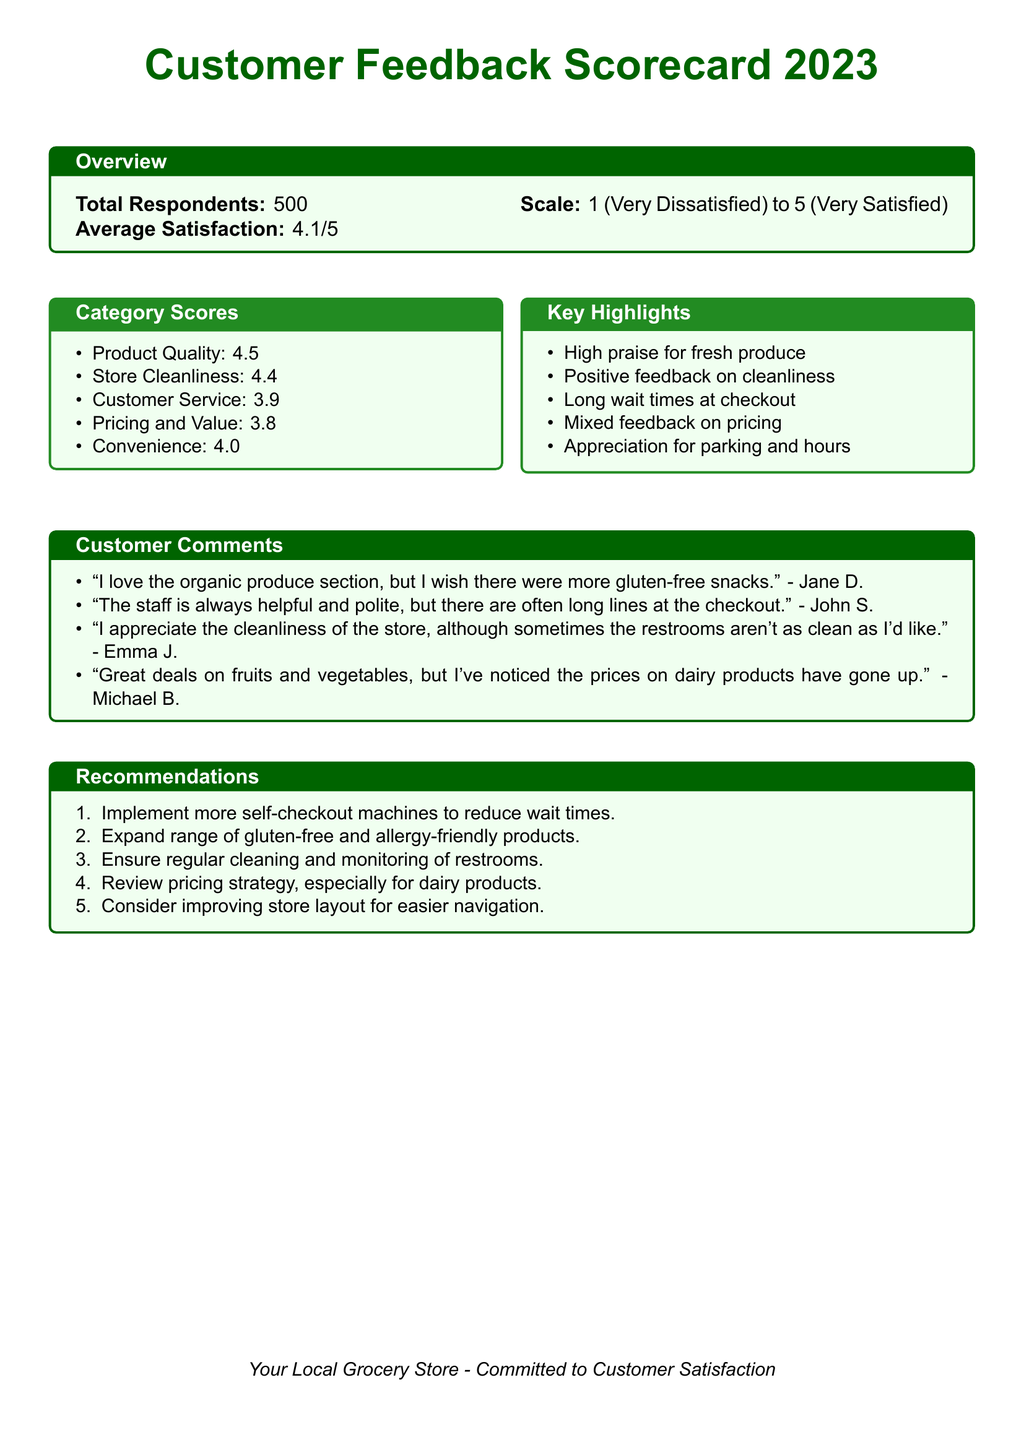What is the total number of respondents? The total number of respondents is stated in the document under the overview section.
Answer: 500 What is the average satisfaction score? The average satisfaction is provided in the overview section of the scorecard.
Answer: 4.1/5 What category received the highest score? The category scores are listed, and the highest score indicates the best-performing aspect.
Answer: Product Quality What issue was highlighted regarding customer service? A key highlight mentions the customers' experience with long wait times at checkout, indicating an issue.
Answer: Long wait times at checkout How many categories were assessed in the feedback? The number of categories can be counted from the category scores section of the document.
Answer: 5 What is a recommendation related to checkout lines? The recommendations list suggests ways to improve service, particularly concerning checkout efficiency.
Answer: Implement more self-checkout machines Which feature did customers appreciate regarding store facilities? The key highlights indicate customer satisfaction with specific store features, mentioned in the feedback section.
Answer: Parking and hours What did Jane D. comment on? The customer comments section lists specific feedback, including Jane D.'s suggestions.
Answer: Organic produce section 